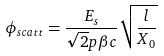Convert formula to latex. <formula><loc_0><loc_0><loc_500><loc_500>\phi _ { s c a t t } = \frac { E _ { s } } { \sqrt { 2 } p \beta c } \sqrt { \frac { l } { X _ { 0 } } }</formula> 